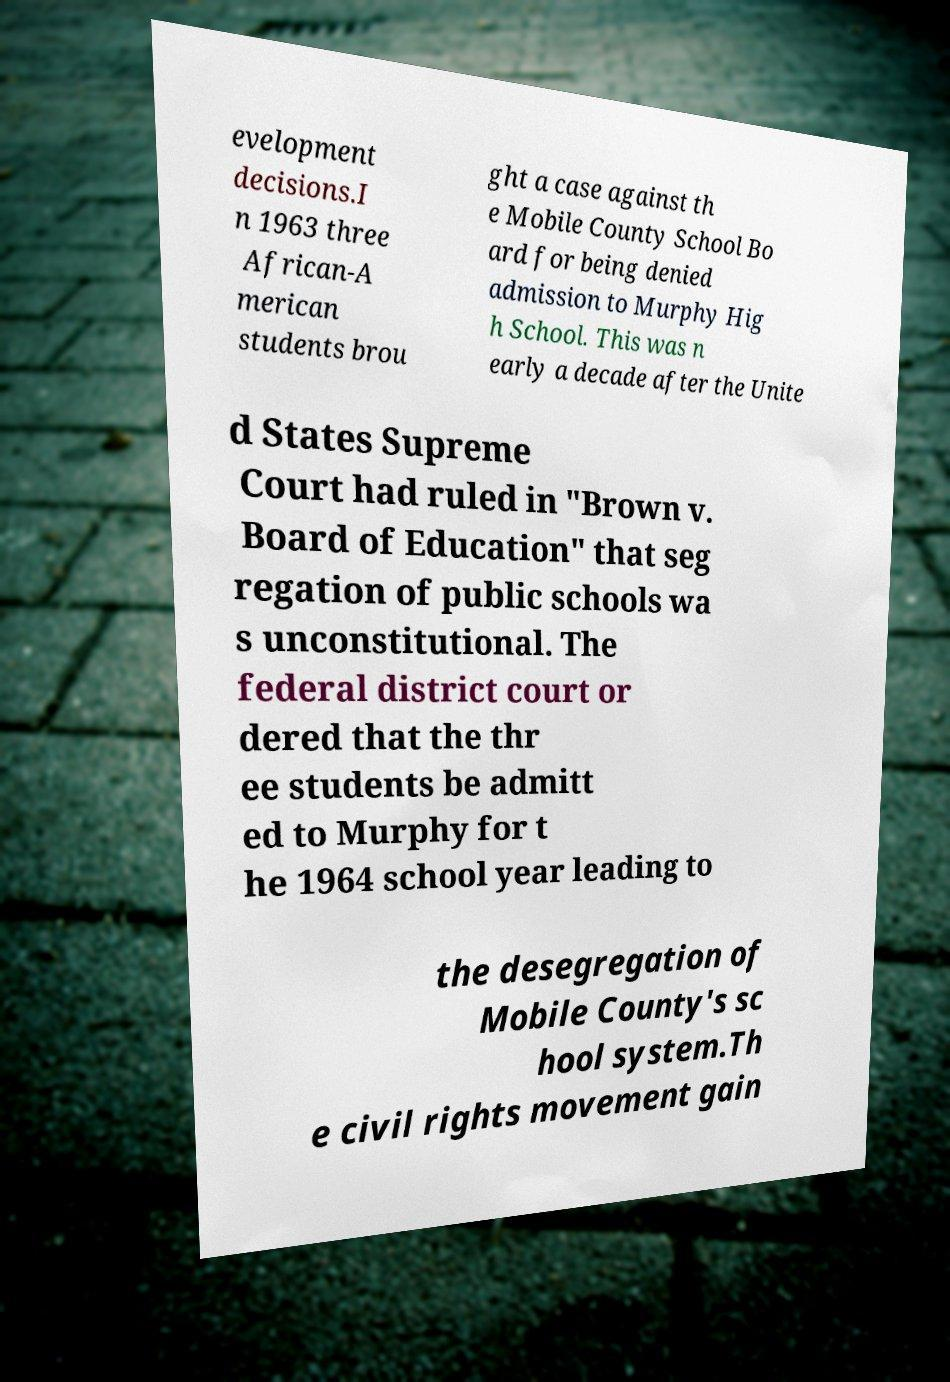Could you assist in decoding the text presented in this image and type it out clearly? evelopment decisions.I n 1963 three African-A merican students brou ght a case against th e Mobile County School Bo ard for being denied admission to Murphy Hig h School. This was n early a decade after the Unite d States Supreme Court had ruled in "Brown v. Board of Education" that seg regation of public schools wa s unconstitutional. The federal district court or dered that the thr ee students be admitt ed to Murphy for t he 1964 school year leading to the desegregation of Mobile County's sc hool system.Th e civil rights movement gain 